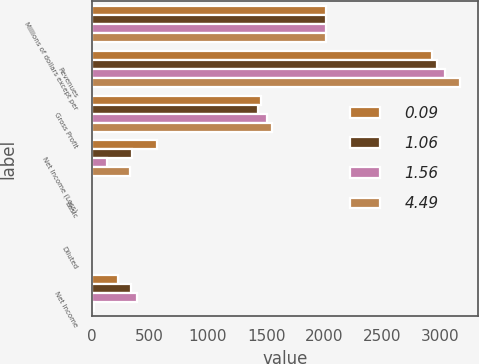Convert chart. <chart><loc_0><loc_0><loc_500><loc_500><stacked_bar_chart><ecel><fcel>Millions of dollars except per<fcel>Revenues<fcel>Gross Profit<fcel>Net Income (Loss)<fcel>Basic<fcel>Diluted<fcel>Net Income<nl><fcel>0.09<fcel>2017<fcel>2922<fcel>1452<fcel>562<fcel>2.64<fcel>2.58<fcel>229<nl><fcel>1.06<fcel>2017<fcel>2969<fcel>1432<fcel>344<fcel>1.61<fcel>1.58<fcel>338<nl><fcel>1.56<fcel>2017<fcel>3035<fcel>1504<fcel>132<fcel>0.75<fcel>0.75<fcel>390<nl><fcel>4.49<fcel>2017<fcel>3166<fcel>1554<fcel>327<fcel>1.27<fcel>1.24<fcel>19<nl></chart> 